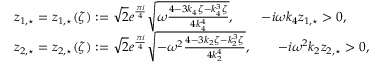Convert formula to latex. <formula><loc_0><loc_0><loc_500><loc_500>\begin{array} { r l } & { z _ { 1 , ^ { * } } = z _ { 1 , ^ { * } } ( \zeta ) \colon = \sqrt { 2 } e ^ { \frac { \pi i } { 4 } } \sqrt { \omega \frac { 4 - 3 k _ { 4 } \zeta - k _ { 4 } ^ { 3 } \zeta } { 4 k _ { 4 } ^ { 4 } } } , \quad - i \omega k _ { 4 } z _ { 1 , ^ { * } } > 0 , } \\ & { z _ { 2 , ^ { * } } = z _ { 2 , ^ { * } } ( \zeta ) \colon = \sqrt { 2 } e ^ { \frac { \pi i } { 4 } } \sqrt { - \omega ^ { 2 } \frac { 4 - 3 k _ { 2 } \zeta - k _ { 2 } ^ { 3 } \zeta } { 4 k _ { 2 } ^ { 4 } } } , \quad - i \omega ^ { 2 } k _ { 2 } z _ { 2 , ^ { * } } > 0 , } \end{array}</formula> 